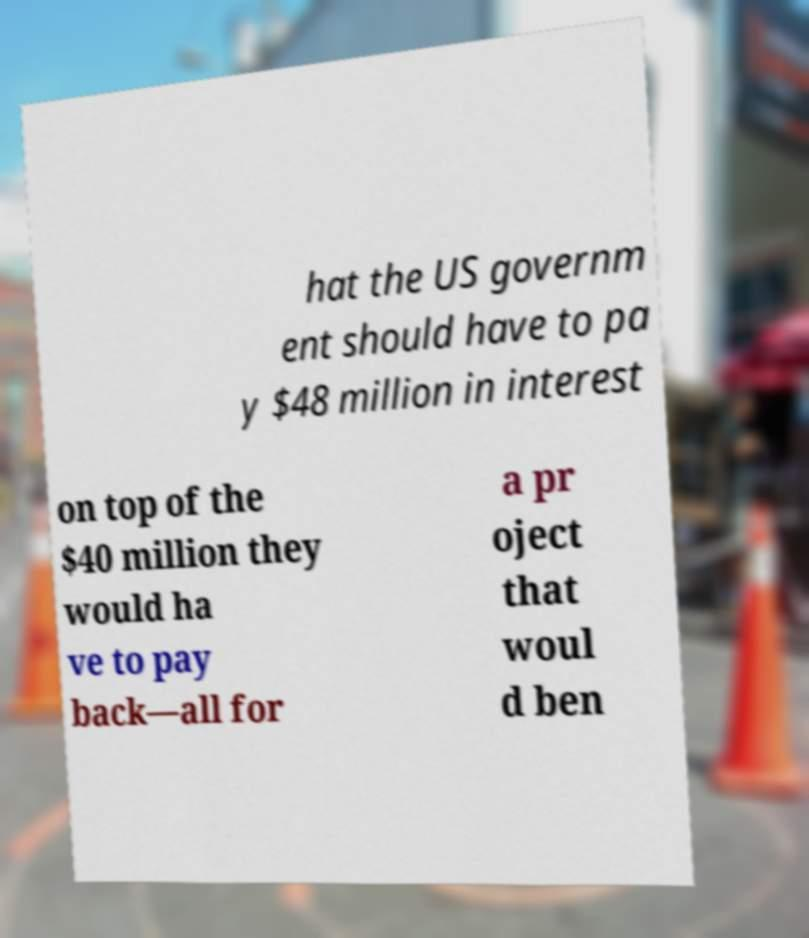I need the written content from this picture converted into text. Can you do that? hat the US governm ent should have to pa y $48 million in interest on top of the $40 million they would ha ve to pay back—all for a pr oject that woul d ben 